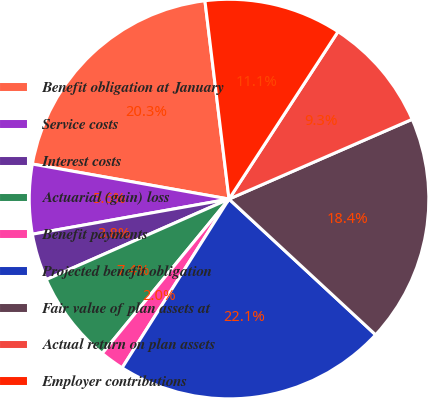Convert chart to OTSL. <chart><loc_0><loc_0><loc_500><loc_500><pie_chart><fcel>Benefit obligation at January<fcel>Service costs<fcel>Interest costs<fcel>Actuarial (gain) loss<fcel>Benefit payments<fcel>Projected benefit obligation<fcel>Fair value of plan assets at<fcel>Actual return on plan assets<fcel>Employer contributions<nl><fcel>20.27%<fcel>5.62%<fcel>3.79%<fcel>7.45%<fcel>1.96%<fcel>22.1%<fcel>18.43%<fcel>9.28%<fcel>11.11%<nl></chart> 